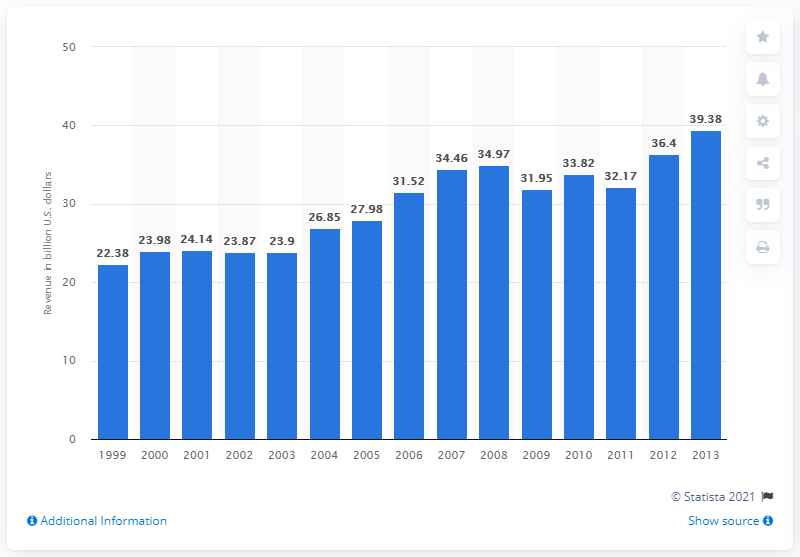List a handful of essential elements in this visual. In 2012, the revenue generated by arts and culture nonprofit organizations was 36.4 billion dollars. 